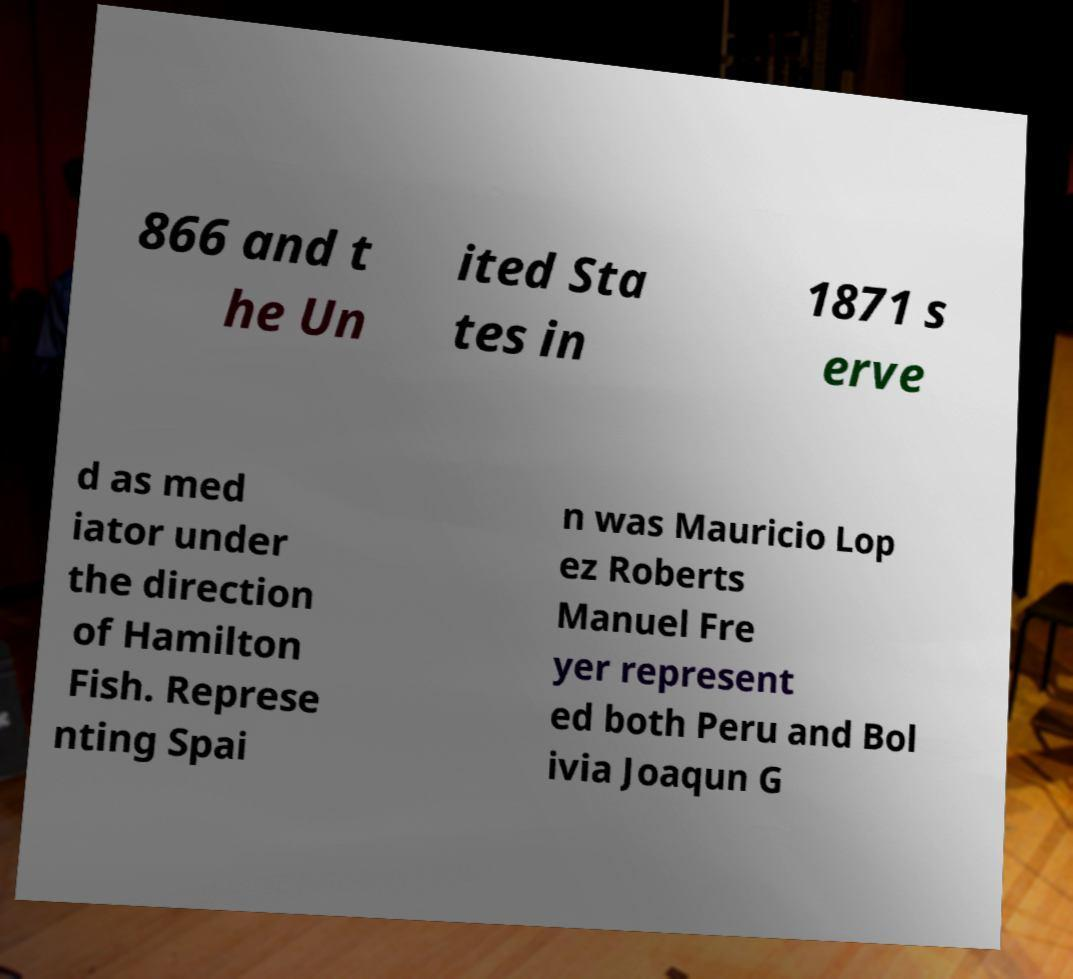Could you extract and type out the text from this image? 866 and t he Un ited Sta tes in 1871 s erve d as med iator under the direction of Hamilton Fish. Represe nting Spai n was Mauricio Lop ez Roberts Manuel Fre yer represent ed both Peru and Bol ivia Joaqun G 